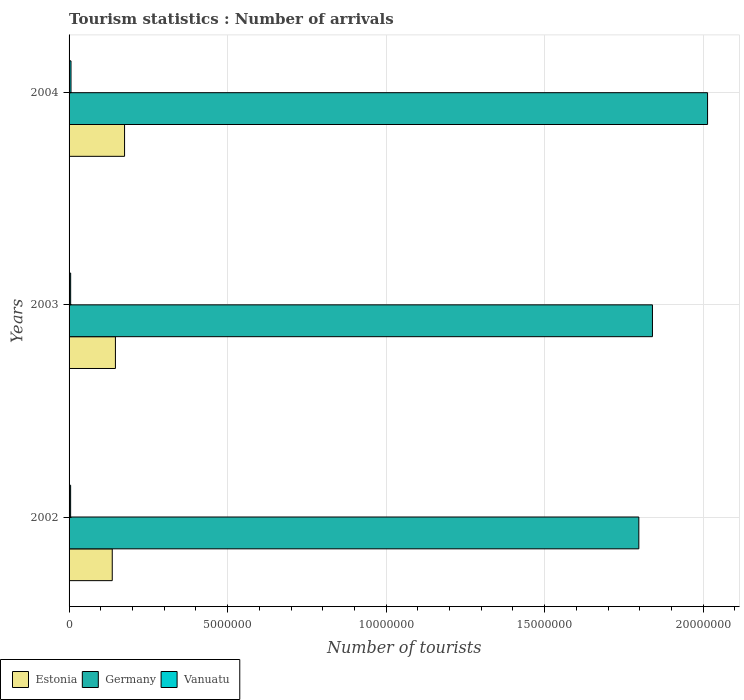How many different coloured bars are there?
Give a very brief answer. 3. What is the number of tourist arrivals in Estonia in 2003?
Make the answer very short. 1.46e+06. Across all years, what is the maximum number of tourist arrivals in Germany?
Provide a succinct answer. 2.01e+07. Across all years, what is the minimum number of tourist arrivals in Germany?
Your answer should be very brief. 1.80e+07. In which year was the number of tourist arrivals in Vanuatu minimum?
Offer a very short reply. 2002. What is the total number of tourist arrivals in Vanuatu in the graph?
Offer a terse response. 1.60e+05. What is the difference between the number of tourist arrivals in Estonia in 2002 and that in 2003?
Your response must be concise. -1.00e+05. What is the difference between the number of tourist arrivals in Germany in 2003 and the number of tourist arrivals in Vanuatu in 2002?
Ensure brevity in your answer.  1.84e+07. What is the average number of tourist arrivals in Germany per year?
Ensure brevity in your answer.  1.88e+07. In the year 2004, what is the difference between the number of tourist arrivals in Estonia and number of tourist arrivals in Vanuatu?
Your response must be concise. 1.69e+06. In how many years, is the number of tourist arrivals in Estonia greater than 16000000 ?
Give a very brief answer. 0. What is the ratio of the number of tourist arrivals in Estonia in 2002 to that in 2003?
Your answer should be compact. 0.93. Is the difference between the number of tourist arrivals in Estonia in 2002 and 2003 greater than the difference between the number of tourist arrivals in Vanuatu in 2002 and 2003?
Offer a terse response. No. What is the difference between the highest and the second highest number of tourist arrivals in Estonia?
Give a very brief answer. 2.88e+05. What is the difference between the highest and the lowest number of tourist arrivals in Estonia?
Provide a short and direct response. 3.88e+05. What does the 3rd bar from the top in 2003 represents?
Keep it short and to the point. Estonia. What does the 1st bar from the bottom in 2002 represents?
Ensure brevity in your answer.  Estonia. How many years are there in the graph?
Ensure brevity in your answer.  3. What is the difference between two consecutive major ticks on the X-axis?
Your response must be concise. 5.00e+06. Are the values on the major ticks of X-axis written in scientific E-notation?
Keep it short and to the point. No. What is the title of the graph?
Your response must be concise. Tourism statistics : Number of arrivals. What is the label or title of the X-axis?
Your answer should be compact. Number of tourists. What is the Number of tourists of Estonia in 2002?
Your answer should be compact. 1.36e+06. What is the Number of tourists in Germany in 2002?
Keep it short and to the point. 1.80e+07. What is the Number of tourists in Vanuatu in 2002?
Your answer should be very brief. 4.90e+04. What is the Number of tourists in Estonia in 2003?
Provide a short and direct response. 1.46e+06. What is the Number of tourists in Germany in 2003?
Provide a short and direct response. 1.84e+07. What is the Number of tourists in Estonia in 2004?
Provide a succinct answer. 1.75e+06. What is the Number of tourists of Germany in 2004?
Provide a short and direct response. 2.01e+07. What is the Number of tourists in Vanuatu in 2004?
Provide a short and direct response. 6.10e+04. Across all years, what is the maximum Number of tourists of Estonia?
Your answer should be very brief. 1.75e+06. Across all years, what is the maximum Number of tourists of Germany?
Provide a short and direct response. 2.01e+07. Across all years, what is the maximum Number of tourists of Vanuatu?
Your answer should be compact. 6.10e+04. Across all years, what is the minimum Number of tourists in Estonia?
Provide a short and direct response. 1.36e+06. Across all years, what is the minimum Number of tourists in Germany?
Your answer should be very brief. 1.80e+07. Across all years, what is the minimum Number of tourists in Vanuatu?
Offer a terse response. 4.90e+04. What is the total Number of tourists of Estonia in the graph?
Your response must be concise. 4.57e+06. What is the total Number of tourists of Germany in the graph?
Your answer should be compact. 5.65e+07. What is the difference between the Number of tourists in Estonia in 2002 and that in 2003?
Give a very brief answer. -1.00e+05. What is the difference between the Number of tourists of Germany in 2002 and that in 2003?
Make the answer very short. -4.30e+05. What is the difference between the Number of tourists of Vanuatu in 2002 and that in 2003?
Provide a short and direct response. -1000. What is the difference between the Number of tourists of Estonia in 2002 and that in 2004?
Offer a terse response. -3.88e+05. What is the difference between the Number of tourists of Germany in 2002 and that in 2004?
Keep it short and to the point. -2.17e+06. What is the difference between the Number of tourists in Vanuatu in 2002 and that in 2004?
Keep it short and to the point. -1.20e+04. What is the difference between the Number of tourists in Estonia in 2003 and that in 2004?
Offer a very short reply. -2.88e+05. What is the difference between the Number of tourists in Germany in 2003 and that in 2004?
Give a very brief answer. -1.74e+06. What is the difference between the Number of tourists of Vanuatu in 2003 and that in 2004?
Keep it short and to the point. -1.10e+04. What is the difference between the Number of tourists of Estonia in 2002 and the Number of tourists of Germany in 2003?
Offer a terse response. -1.70e+07. What is the difference between the Number of tourists in Estonia in 2002 and the Number of tourists in Vanuatu in 2003?
Offer a terse response. 1.31e+06. What is the difference between the Number of tourists in Germany in 2002 and the Number of tourists in Vanuatu in 2003?
Provide a short and direct response. 1.79e+07. What is the difference between the Number of tourists in Estonia in 2002 and the Number of tourists in Germany in 2004?
Your answer should be very brief. -1.88e+07. What is the difference between the Number of tourists in Estonia in 2002 and the Number of tourists in Vanuatu in 2004?
Provide a short and direct response. 1.30e+06. What is the difference between the Number of tourists of Germany in 2002 and the Number of tourists of Vanuatu in 2004?
Provide a succinct answer. 1.79e+07. What is the difference between the Number of tourists of Estonia in 2003 and the Number of tourists of Germany in 2004?
Offer a terse response. -1.87e+07. What is the difference between the Number of tourists of Estonia in 2003 and the Number of tourists of Vanuatu in 2004?
Your answer should be very brief. 1.40e+06. What is the difference between the Number of tourists of Germany in 2003 and the Number of tourists of Vanuatu in 2004?
Keep it short and to the point. 1.83e+07. What is the average Number of tourists in Estonia per year?
Provide a short and direct response. 1.52e+06. What is the average Number of tourists of Germany per year?
Make the answer very short. 1.88e+07. What is the average Number of tourists in Vanuatu per year?
Make the answer very short. 5.33e+04. In the year 2002, what is the difference between the Number of tourists of Estonia and Number of tourists of Germany?
Offer a terse response. -1.66e+07. In the year 2002, what is the difference between the Number of tourists of Estonia and Number of tourists of Vanuatu?
Provide a succinct answer. 1.31e+06. In the year 2002, what is the difference between the Number of tourists in Germany and Number of tourists in Vanuatu?
Your answer should be compact. 1.79e+07. In the year 2003, what is the difference between the Number of tourists in Estonia and Number of tourists in Germany?
Provide a succinct answer. -1.69e+07. In the year 2003, what is the difference between the Number of tourists in Estonia and Number of tourists in Vanuatu?
Your response must be concise. 1.41e+06. In the year 2003, what is the difference between the Number of tourists in Germany and Number of tourists in Vanuatu?
Your response must be concise. 1.83e+07. In the year 2004, what is the difference between the Number of tourists in Estonia and Number of tourists in Germany?
Your answer should be very brief. -1.84e+07. In the year 2004, what is the difference between the Number of tourists in Estonia and Number of tourists in Vanuatu?
Offer a terse response. 1.69e+06. In the year 2004, what is the difference between the Number of tourists of Germany and Number of tourists of Vanuatu?
Give a very brief answer. 2.01e+07. What is the ratio of the Number of tourists in Estonia in 2002 to that in 2003?
Offer a terse response. 0.93. What is the ratio of the Number of tourists of Germany in 2002 to that in 2003?
Provide a succinct answer. 0.98. What is the ratio of the Number of tourists of Estonia in 2002 to that in 2004?
Your answer should be very brief. 0.78. What is the ratio of the Number of tourists of Germany in 2002 to that in 2004?
Keep it short and to the point. 0.89. What is the ratio of the Number of tourists of Vanuatu in 2002 to that in 2004?
Provide a succinct answer. 0.8. What is the ratio of the Number of tourists in Estonia in 2003 to that in 2004?
Your answer should be very brief. 0.84. What is the ratio of the Number of tourists in Germany in 2003 to that in 2004?
Offer a terse response. 0.91. What is the ratio of the Number of tourists of Vanuatu in 2003 to that in 2004?
Ensure brevity in your answer.  0.82. What is the difference between the highest and the second highest Number of tourists of Estonia?
Your answer should be compact. 2.88e+05. What is the difference between the highest and the second highest Number of tourists in Germany?
Ensure brevity in your answer.  1.74e+06. What is the difference between the highest and the second highest Number of tourists in Vanuatu?
Your answer should be compact. 1.10e+04. What is the difference between the highest and the lowest Number of tourists in Estonia?
Your response must be concise. 3.88e+05. What is the difference between the highest and the lowest Number of tourists in Germany?
Make the answer very short. 2.17e+06. What is the difference between the highest and the lowest Number of tourists in Vanuatu?
Your answer should be very brief. 1.20e+04. 